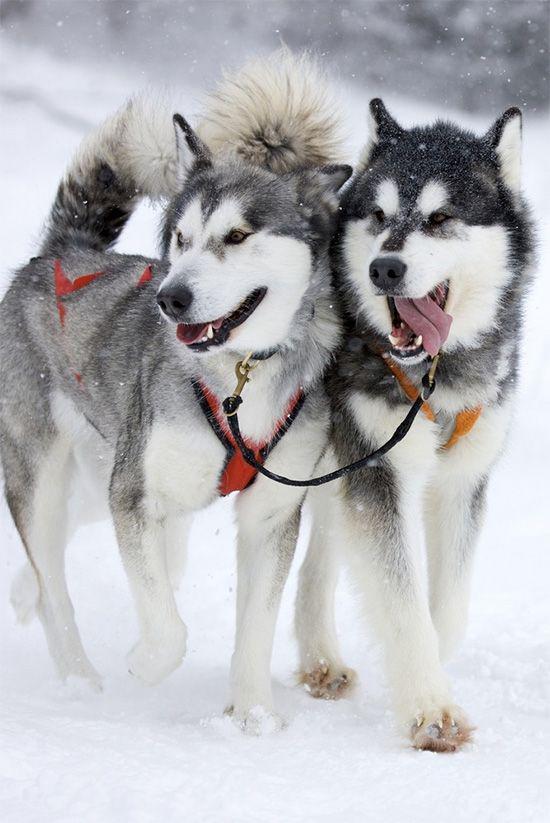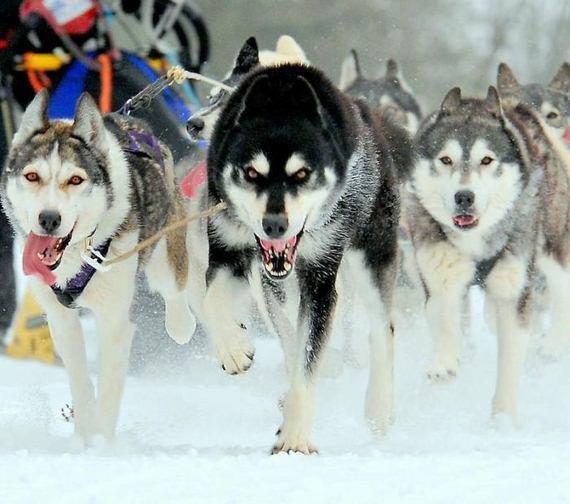The first image is the image on the left, the second image is the image on the right. Evaluate the accuracy of this statement regarding the images: "There is a person visible behind a pack of huskies.". Is it true? Answer yes or no. No. The first image is the image on the left, the second image is the image on the right. For the images shown, is this caption "The image on the left has more than six dogs pulling the sleigh." true? Answer yes or no. No. 